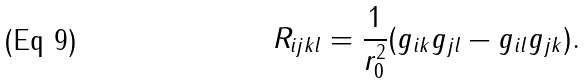<formula> <loc_0><loc_0><loc_500><loc_500>R _ { i j k l } = \frac { 1 } { r _ { 0 } ^ { 2 } } ( g _ { i k } g _ { j l } - g _ { i l } g _ { j k } ) .</formula> 